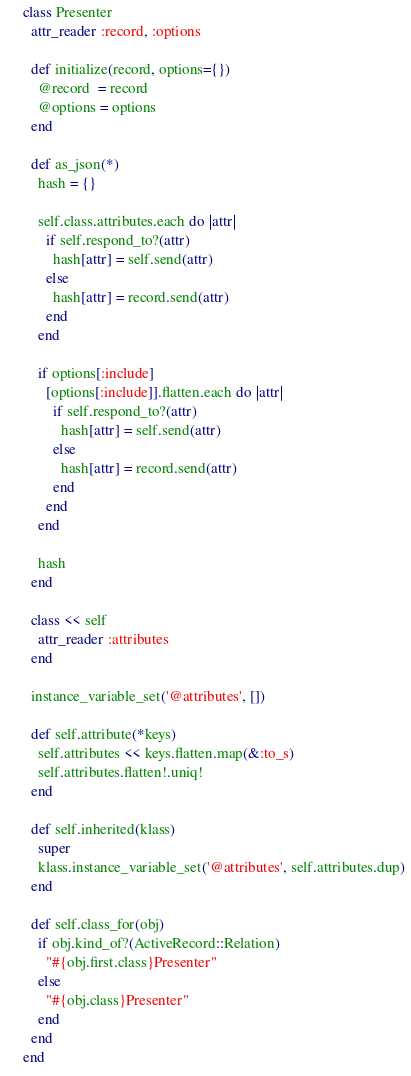Convert code to text. <code><loc_0><loc_0><loc_500><loc_500><_Ruby_>class Presenter
  attr_reader :record, :options

  def initialize(record, options={})
    @record  = record
    @options = options
  end

  def as_json(*)
    hash = {}

    self.class.attributes.each do |attr|
      if self.respond_to?(attr)
        hash[attr] = self.send(attr)
      else
        hash[attr] = record.send(attr)
      end
    end

    if options[:include]
      [options[:include]].flatten.each do |attr|
        if self.respond_to?(attr)
          hash[attr] = self.send(attr)
        else
          hash[attr] = record.send(attr)
        end
      end
    end

    hash
  end

  class << self
    attr_reader :attributes
  end

  instance_variable_set('@attributes', [])

  def self.attribute(*keys)
    self.attributes << keys.flatten.map(&:to_s)
    self.attributes.flatten!.uniq!
  end

  def self.inherited(klass)
    super
    klass.instance_variable_set('@attributes', self.attributes.dup)
  end

  def self.class_for(obj)
    if obj.kind_of?(ActiveRecord::Relation)
      "#{obj.first.class}Presenter"
    else
      "#{obj.class}Presenter"
    end
  end
end</code> 